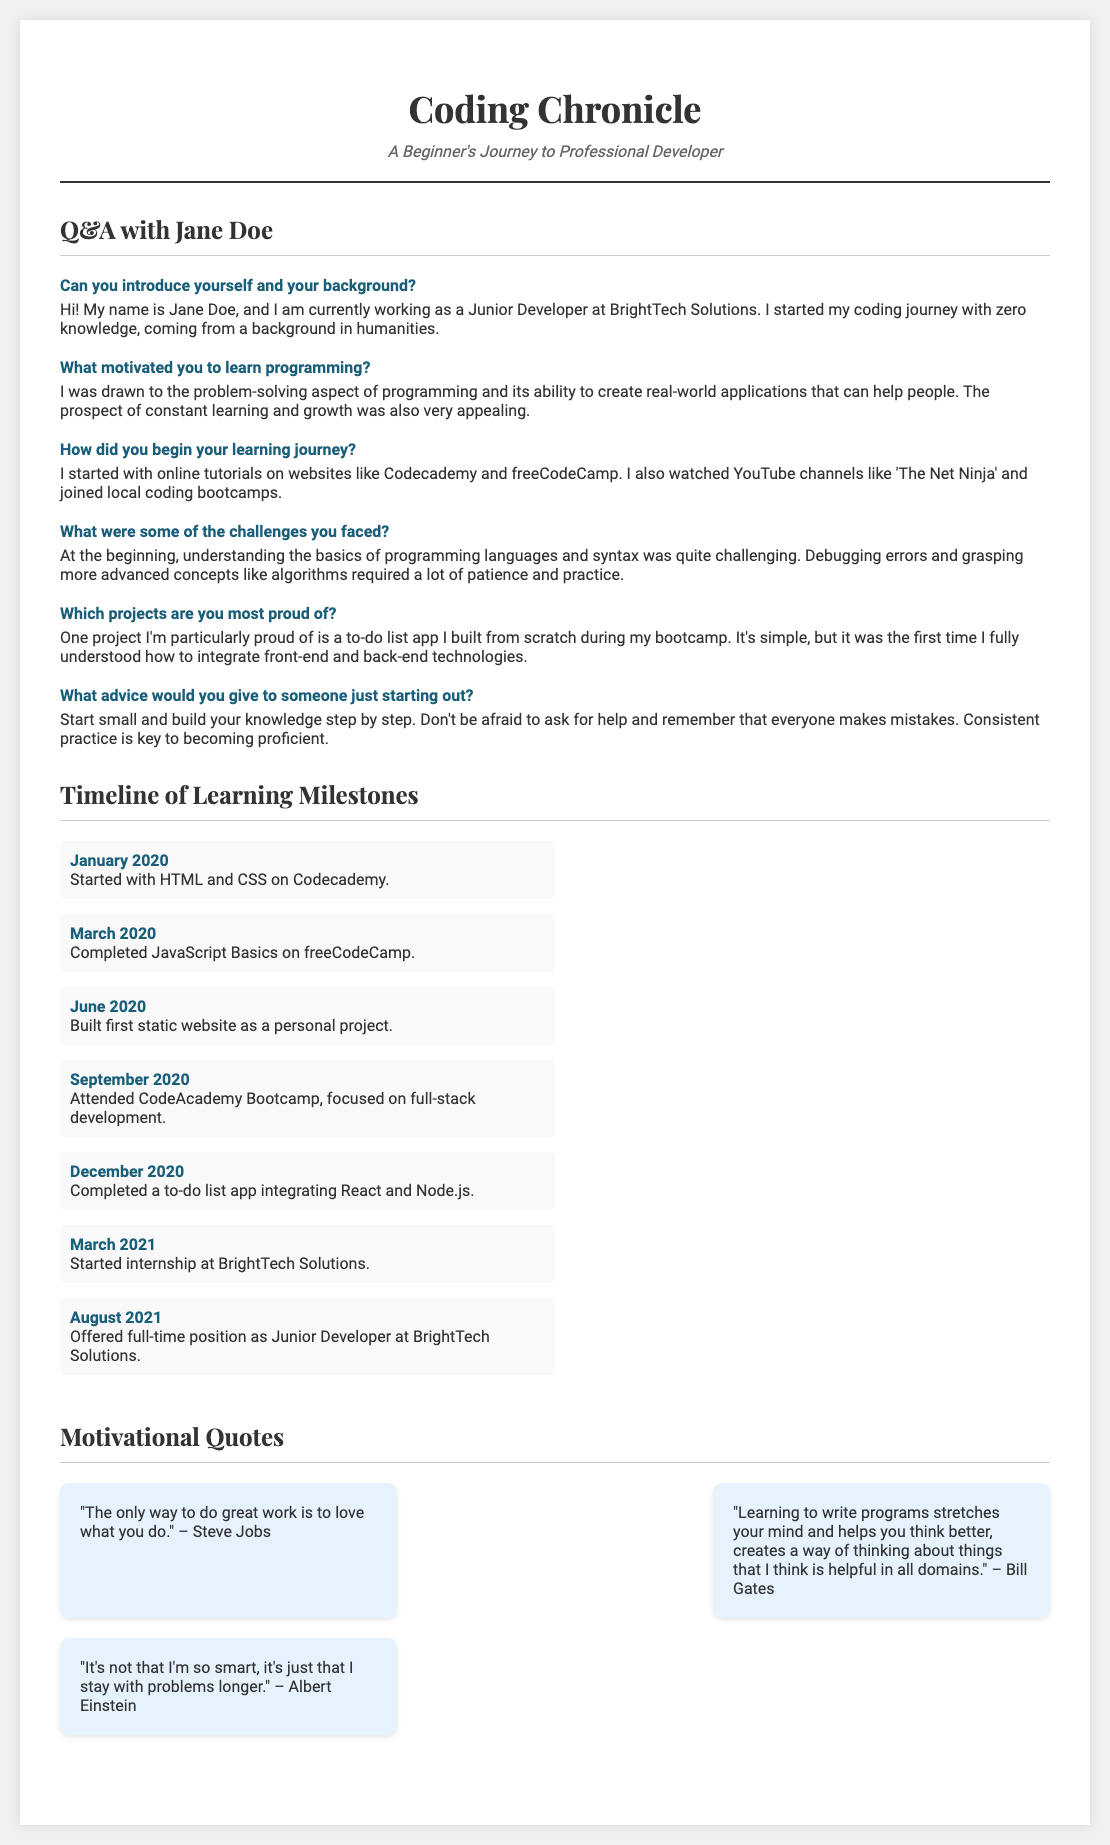What is the interviewee's name? The interviewee in the document is introduced as Jane Doe.
Answer: Jane Doe What company does Jane work for? Jane mentions she works at BrightTech Solutions.
Answer: BrightTech Solutions What is the first programming language Jane learned? Jane started with HTML and CSS on Codecademy in January 2020.
Answer: HTML and CSS How many months after starting her journey did Jane complete JavaScript Basics? Jane completed JavaScript Basics in March 2020, which is two months after starting in January 2020.
Answer: 2 months What project did Jane build that she is particularly proud of? Jane is proud of a to-do list app she built from scratch during her bootcamp.
Answer: To-do list app What quote is attributed to Steve Jobs in the motivational section? The quote attributed to Steve Jobs speaks about doing great work with love.
Answer: "The only way to do great work is to love what you do." When did Jane begin her internship at BrightTech Solutions? Jane started her internship in March 2021.
Answer: March 2021 What was the main focus of Jane's bootcamp? The bootcamp that Jane attended focused on full-stack development.
Answer: Full-stack development 